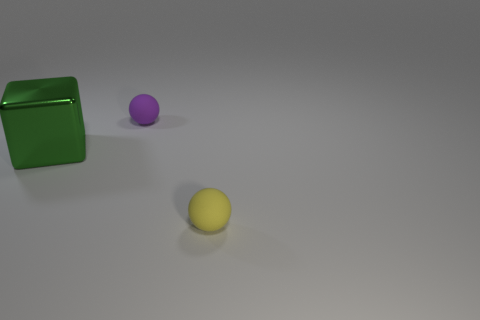Subtract all spheres. How many objects are left? 1 Add 2 tiny cyan shiny spheres. How many objects exist? 5 Add 2 big purple cylinders. How many big purple cylinders exist? 2 Subtract 1 purple spheres. How many objects are left? 2 Subtract 1 balls. How many balls are left? 1 Subtract all cyan spheres. Subtract all blue cylinders. How many spheres are left? 2 Subtract all red blocks. How many purple balls are left? 1 Subtract all purple objects. Subtract all large metallic things. How many objects are left? 1 Add 1 metal cubes. How many metal cubes are left? 2 